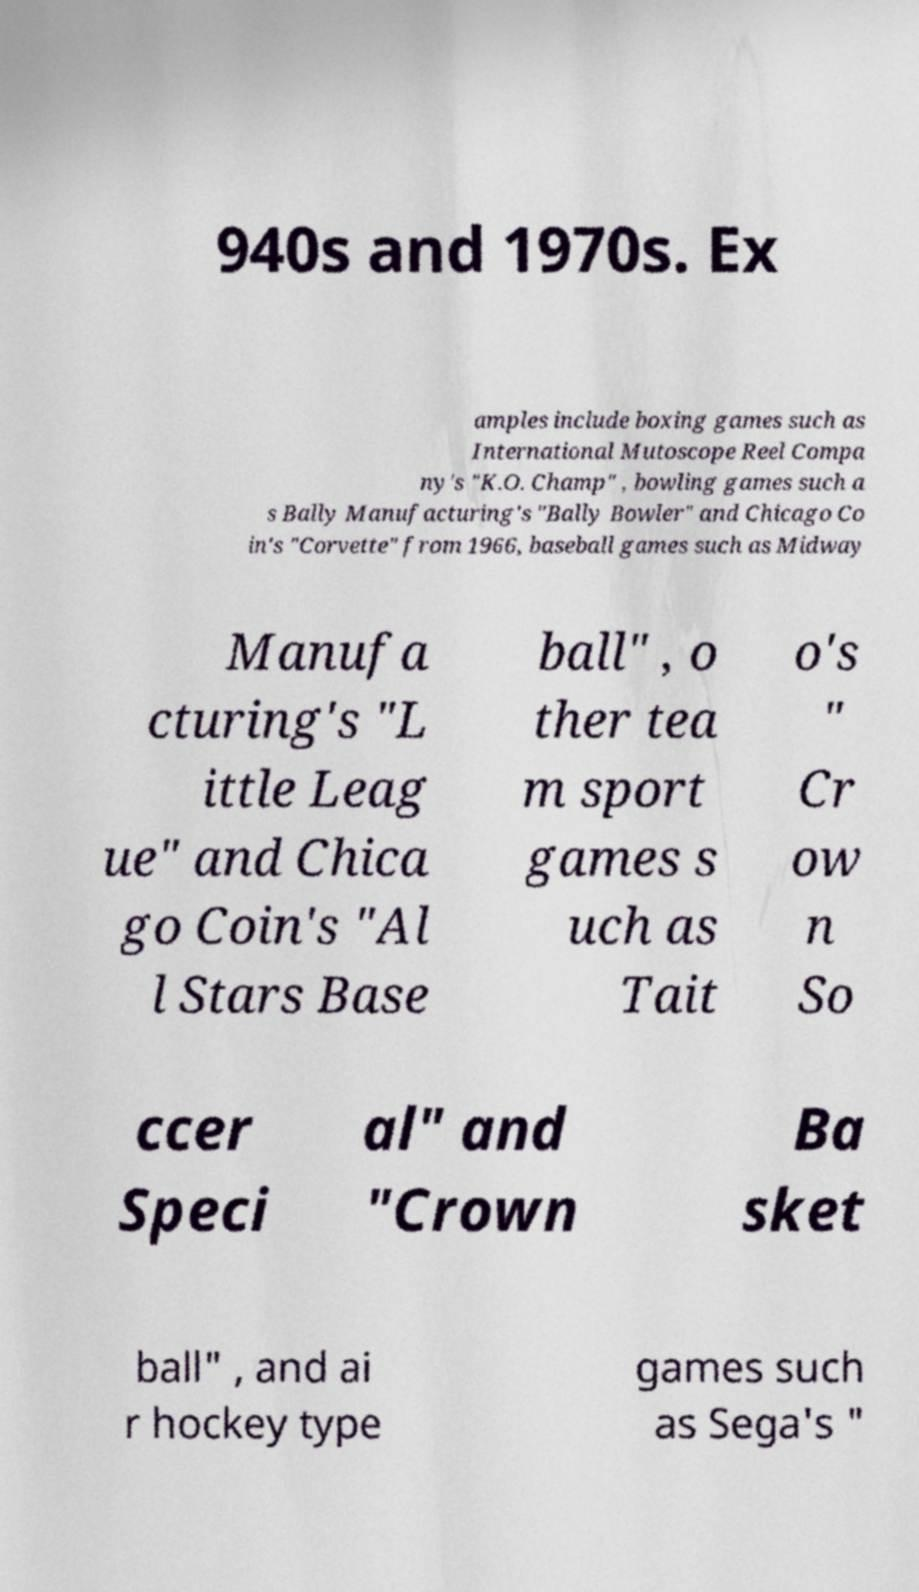I need the written content from this picture converted into text. Can you do that? 940s and 1970s. Ex amples include boxing games such as International Mutoscope Reel Compa ny's "K.O. Champ" , bowling games such a s Bally Manufacturing's "Bally Bowler" and Chicago Co in's "Corvette" from 1966, baseball games such as Midway Manufa cturing's "L ittle Leag ue" and Chica go Coin's "Al l Stars Base ball" , o ther tea m sport games s uch as Tait o's " Cr ow n So ccer Speci al" and "Crown Ba sket ball" , and ai r hockey type games such as Sega's " 